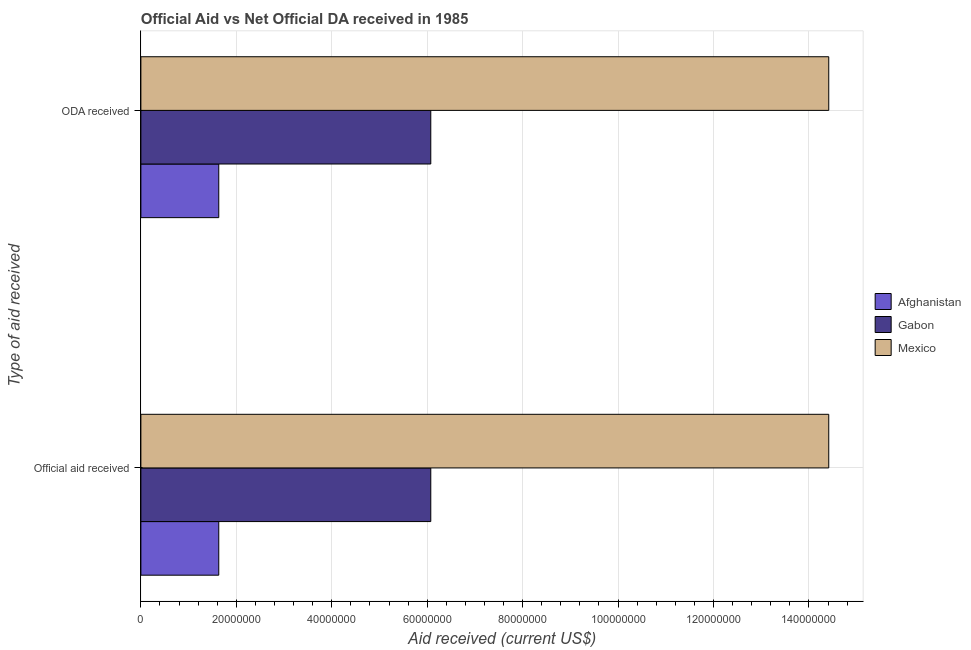How many different coloured bars are there?
Provide a short and direct response. 3. How many groups of bars are there?
Offer a very short reply. 2. How many bars are there on the 1st tick from the top?
Make the answer very short. 3. How many bars are there on the 2nd tick from the bottom?
Keep it short and to the point. 3. What is the label of the 1st group of bars from the top?
Provide a short and direct response. ODA received. What is the official aid received in Gabon?
Provide a succinct answer. 6.08e+07. Across all countries, what is the maximum official aid received?
Offer a very short reply. 1.44e+08. Across all countries, what is the minimum official aid received?
Offer a very short reply. 1.63e+07. In which country was the oda received maximum?
Make the answer very short. Mexico. In which country was the official aid received minimum?
Offer a very short reply. Afghanistan. What is the total official aid received in the graph?
Your answer should be compact. 2.21e+08. What is the difference between the oda received in Afghanistan and that in Gabon?
Keep it short and to the point. -4.44e+07. What is the difference between the official aid received in Gabon and the oda received in Mexico?
Ensure brevity in your answer.  -8.34e+07. What is the average oda received per country?
Offer a very short reply. 7.37e+07. What is the difference between the oda received and official aid received in Afghanistan?
Keep it short and to the point. 0. What is the ratio of the official aid received in Afghanistan to that in Gabon?
Ensure brevity in your answer.  0.27. Is the official aid received in Gabon less than that in Mexico?
Ensure brevity in your answer.  Yes. What does the 3rd bar from the top in ODA received represents?
Offer a terse response. Afghanistan. What does the 2nd bar from the bottom in Official aid received represents?
Keep it short and to the point. Gabon. Are all the bars in the graph horizontal?
Provide a short and direct response. Yes. Where does the legend appear in the graph?
Provide a short and direct response. Center right. How many legend labels are there?
Provide a short and direct response. 3. How are the legend labels stacked?
Give a very brief answer. Vertical. What is the title of the graph?
Your answer should be very brief. Official Aid vs Net Official DA received in 1985 . Does "Tunisia" appear as one of the legend labels in the graph?
Give a very brief answer. No. What is the label or title of the X-axis?
Offer a terse response. Aid received (current US$). What is the label or title of the Y-axis?
Provide a short and direct response. Type of aid received. What is the Aid received (current US$) of Afghanistan in Official aid received?
Your answer should be compact. 1.63e+07. What is the Aid received (current US$) of Gabon in Official aid received?
Your answer should be compact. 6.08e+07. What is the Aid received (current US$) of Mexico in Official aid received?
Your answer should be very brief. 1.44e+08. What is the Aid received (current US$) in Afghanistan in ODA received?
Provide a short and direct response. 1.63e+07. What is the Aid received (current US$) in Gabon in ODA received?
Make the answer very short. 6.08e+07. What is the Aid received (current US$) in Mexico in ODA received?
Your answer should be compact. 1.44e+08. Across all Type of aid received, what is the maximum Aid received (current US$) in Afghanistan?
Your response must be concise. 1.63e+07. Across all Type of aid received, what is the maximum Aid received (current US$) in Gabon?
Your response must be concise. 6.08e+07. Across all Type of aid received, what is the maximum Aid received (current US$) of Mexico?
Your answer should be compact. 1.44e+08. Across all Type of aid received, what is the minimum Aid received (current US$) of Afghanistan?
Give a very brief answer. 1.63e+07. Across all Type of aid received, what is the minimum Aid received (current US$) of Gabon?
Provide a short and direct response. 6.08e+07. Across all Type of aid received, what is the minimum Aid received (current US$) of Mexico?
Provide a succinct answer. 1.44e+08. What is the total Aid received (current US$) in Afghanistan in the graph?
Make the answer very short. 3.26e+07. What is the total Aid received (current US$) of Gabon in the graph?
Provide a succinct answer. 1.22e+08. What is the total Aid received (current US$) in Mexico in the graph?
Offer a very short reply. 2.88e+08. What is the difference between the Aid received (current US$) of Gabon in Official aid received and that in ODA received?
Offer a terse response. 0. What is the difference between the Aid received (current US$) of Mexico in Official aid received and that in ODA received?
Offer a very short reply. 0. What is the difference between the Aid received (current US$) in Afghanistan in Official aid received and the Aid received (current US$) in Gabon in ODA received?
Ensure brevity in your answer.  -4.44e+07. What is the difference between the Aid received (current US$) of Afghanistan in Official aid received and the Aid received (current US$) of Mexico in ODA received?
Provide a succinct answer. -1.28e+08. What is the difference between the Aid received (current US$) of Gabon in Official aid received and the Aid received (current US$) of Mexico in ODA received?
Your answer should be compact. -8.34e+07. What is the average Aid received (current US$) of Afghanistan per Type of aid received?
Give a very brief answer. 1.63e+07. What is the average Aid received (current US$) in Gabon per Type of aid received?
Your response must be concise. 6.08e+07. What is the average Aid received (current US$) in Mexico per Type of aid received?
Give a very brief answer. 1.44e+08. What is the difference between the Aid received (current US$) of Afghanistan and Aid received (current US$) of Gabon in Official aid received?
Give a very brief answer. -4.44e+07. What is the difference between the Aid received (current US$) of Afghanistan and Aid received (current US$) of Mexico in Official aid received?
Your answer should be compact. -1.28e+08. What is the difference between the Aid received (current US$) in Gabon and Aid received (current US$) in Mexico in Official aid received?
Provide a short and direct response. -8.34e+07. What is the difference between the Aid received (current US$) in Afghanistan and Aid received (current US$) in Gabon in ODA received?
Offer a very short reply. -4.44e+07. What is the difference between the Aid received (current US$) of Afghanistan and Aid received (current US$) of Mexico in ODA received?
Offer a terse response. -1.28e+08. What is the difference between the Aid received (current US$) in Gabon and Aid received (current US$) in Mexico in ODA received?
Your response must be concise. -8.34e+07. What is the ratio of the Aid received (current US$) of Gabon in Official aid received to that in ODA received?
Ensure brevity in your answer.  1. What is the difference between the highest and the second highest Aid received (current US$) of Mexico?
Provide a short and direct response. 0. 